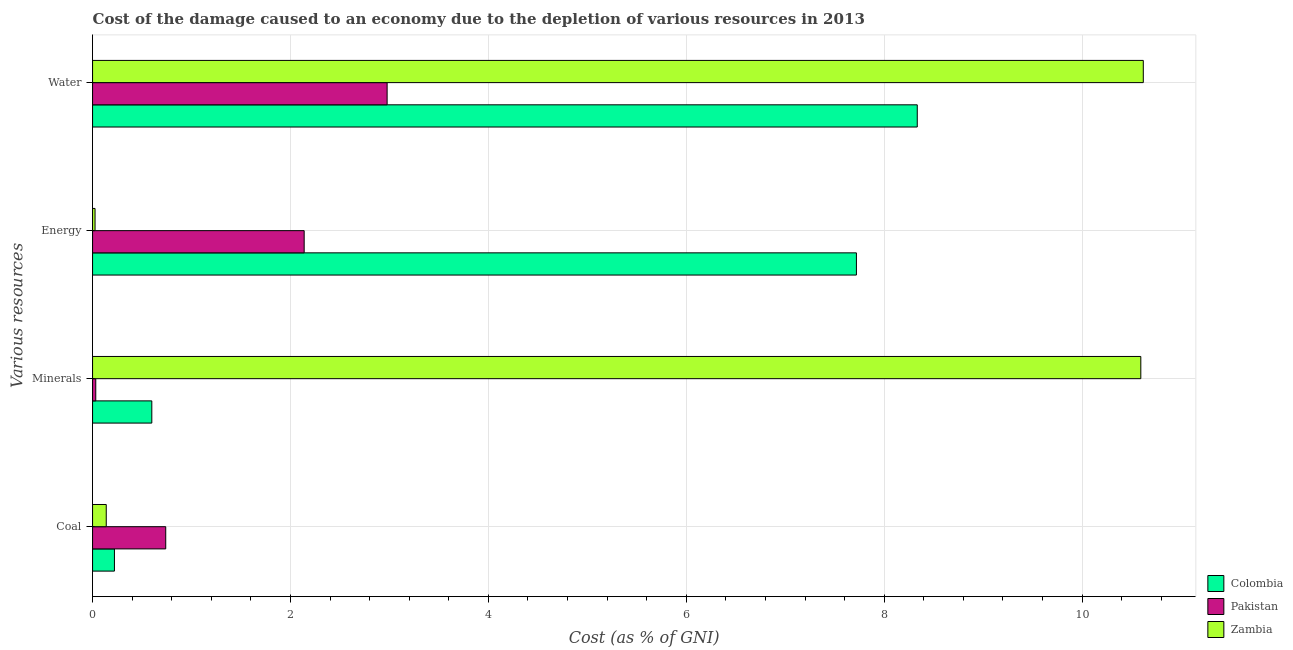How many different coloured bars are there?
Your response must be concise. 3. How many groups of bars are there?
Your answer should be compact. 4. Are the number of bars per tick equal to the number of legend labels?
Offer a terse response. Yes. What is the label of the 3rd group of bars from the top?
Your response must be concise. Minerals. What is the cost of damage due to depletion of water in Pakistan?
Keep it short and to the point. 2.98. Across all countries, what is the maximum cost of damage due to depletion of energy?
Keep it short and to the point. 7.72. Across all countries, what is the minimum cost of damage due to depletion of energy?
Offer a terse response. 0.03. In which country was the cost of damage due to depletion of minerals maximum?
Provide a short and direct response. Zambia. In which country was the cost of damage due to depletion of water minimum?
Your answer should be compact. Pakistan. What is the total cost of damage due to depletion of water in the graph?
Offer a terse response. 21.93. What is the difference between the cost of damage due to depletion of water in Colombia and that in Pakistan?
Ensure brevity in your answer.  5.36. What is the difference between the cost of damage due to depletion of energy in Colombia and the cost of damage due to depletion of water in Pakistan?
Give a very brief answer. 4.74. What is the average cost of damage due to depletion of coal per country?
Give a very brief answer. 0.37. What is the difference between the cost of damage due to depletion of minerals and cost of damage due to depletion of energy in Pakistan?
Ensure brevity in your answer.  -2.11. What is the ratio of the cost of damage due to depletion of energy in Zambia to that in Pakistan?
Offer a terse response. 0.01. Is the difference between the cost of damage due to depletion of minerals in Pakistan and Zambia greater than the difference between the cost of damage due to depletion of energy in Pakistan and Zambia?
Make the answer very short. No. What is the difference between the highest and the second highest cost of damage due to depletion of water?
Provide a succinct answer. 2.28. What is the difference between the highest and the lowest cost of damage due to depletion of minerals?
Make the answer very short. 10.56. What does the 1st bar from the top in Water represents?
Offer a terse response. Zambia. Is it the case that in every country, the sum of the cost of damage due to depletion of coal and cost of damage due to depletion of minerals is greater than the cost of damage due to depletion of energy?
Offer a terse response. No. How many bars are there?
Your answer should be very brief. 12. Are all the bars in the graph horizontal?
Provide a short and direct response. Yes. What is the difference between two consecutive major ticks on the X-axis?
Offer a terse response. 2. Where does the legend appear in the graph?
Your response must be concise. Bottom right. How many legend labels are there?
Provide a short and direct response. 3. What is the title of the graph?
Offer a very short reply. Cost of the damage caused to an economy due to the depletion of various resources in 2013 . What is the label or title of the X-axis?
Your answer should be very brief. Cost (as % of GNI). What is the label or title of the Y-axis?
Your response must be concise. Various resources. What is the Cost (as % of GNI) of Colombia in Coal?
Your answer should be compact. 0.22. What is the Cost (as % of GNI) in Pakistan in Coal?
Give a very brief answer. 0.74. What is the Cost (as % of GNI) of Zambia in Coal?
Provide a short and direct response. 0.14. What is the Cost (as % of GNI) in Colombia in Minerals?
Ensure brevity in your answer.  0.6. What is the Cost (as % of GNI) in Pakistan in Minerals?
Make the answer very short. 0.03. What is the Cost (as % of GNI) of Zambia in Minerals?
Offer a very short reply. 10.59. What is the Cost (as % of GNI) of Colombia in Energy?
Offer a terse response. 7.72. What is the Cost (as % of GNI) in Pakistan in Energy?
Ensure brevity in your answer.  2.14. What is the Cost (as % of GNI) in Zambia in Energy?
Give a very brief answer. 0.03. What is the Cost (as % of GNI) of Colombia in Water?
Your answer should be compact. 8.33. What is the Cost (as % of GNI) in Pakistan in Water?
Offer a very short reply. 2.98. What is the Cost (as % of GNI) in Zambia in Water?
Your response must be concise. 10.62. Across all Various resources, what is the maximum Cost (as % of GNI) in Colombia?
Give a very brief answer. 8.33. Across all Various resources, what is the maximum Cost (as % of GNI) in Pakistan?
Your answer should be very brief. 2.98. Across all Various resources, what is the maximum Cost (as % of GNI) in Zambia?
Offer a very short reply. 10.62. Across all Various resources, what is the minimum Cost (as % of GNI) of Colombia?
Your response must be concise. 0.22. Across all Various resources, what is the minimum Cost (as % of GNI) of Pakistan?
Keep it short and to the point. 0.03. Across all Various resources, what is the minimum Cost (as % of GNI) of Zambia?
Your answer should be compact. 0.03. What is the total Cost (as % of GNI) in Colombia in the graph?
Provide a short and direct response. 16.87. What is the total Cost (as % of GNI) of Pakistan in the graph?
Your response must be concise. 5.89. What is the total Cost (as % of GNI) in Zambia in the graph?
Offer a very short reply. 21.38. What is the difference between the Cost (as % of GNI) in Colombia in Coal and that in Minerals?
Your response must be concise. -0.38. What is the difference between the Cost (as % of GNI) in Pakistan in Coal and that in Minerals?
Offer a terse response. 0.71. What is the difference between the Cost (as % of GNI) in Zambia in Coal and that in Minerals?
Offer a very short reply. -10.46. What is the difference between the Cost (as % of GNI) in Colombia in Coal and that in Energy?
Your response must be concise. -7.5. What is the difference between the Cost (as % of GNI) of Pakistan in Coal and that in Energy?
Keep it short and to the point. -1.4. What is the difference between the Cost (as % of GNI) in Zambia in Coal and that in Energy?
Your answer should be compact. 0.11. What is the difference between the Cost (as % of GNI) in Colombia in Coal and that in Water?
Your answer should be very brief. -8.11. What is the difference between the Cost (as % of GNI) of Pakistan in Coal and that in Water?
Provide a short and direct response. -2.24. What is the difference between the Cost (as % of GNI) of Zambia in Coal and that in Water?
Your response must be concise. -10.48. What is the difference between the Cost (as % of GNI) of Colombia in Minerals and that in Energy?
Offer a very short reply. -7.12. What is the difference between the Cost (as % of GNI) in Pakistan in Minerals and that in Energy?
Give a very brief answer. -2.11. What is the difference between the Cost (as % of GNI) in Zambia in Minerals and that in Energy?
Make the answer very short. 10.57. What is the difference between the Cost (as % of GNI) in Colombia in Minerals and that in Water?
Provide a succinct answer. -7.74. What is the difference between the Cost (as % of GNI) in Pakistan in Minerals and that in Water?
Make the answer very short. -2.94. What is the difference between the Cost (as % of GNI) in Zambia in Minerals and that in Water?
Give a very brief answer. -0.03. What is the difference between the Cost (as % of GNI) in Colombia in Energy and that in Water?
Give a very brief answer. -0.61. What is the difference between the Cost (as % of GNI) of Pakistan in Energy and that in Water?
Offer a terse response. -0.84. What is the difference between the Cost (as % of GNI) of Zambia in Energy and that in Water?
Ensure brevity in your answer.  -10.59. What is the difference between the Cost (as % of GNI) in Colombia in Coal and the Cost (as % of GNI) in Pakistan in Minerals?
Keep it short and to the point. 0.19. What is the difference between the Cost (as % of GNI) of Colombia in Coal and the Cost (as % of GNI) of Zambia in Minerals?
Ensure brevity in your answer.  -10.37. What is the difference between the Cost (as % of GNI) in Pakistan in Coal and the Cost (as % of GNI) in Zambia in Minerals?
Ensure brevity in your answer.  -9.85. What is the difference between the Cost (as % of GNI) in Colombia in Coal and the Cost (as % of GNI) in Pakistan in Energy?
Offer a terse response. -1.92. What is the difference between the Cost (as % of GNI) of Colombia in Coal and the Cost (as % of GNI) of Zambia in Energy?
Provide a succinct answer. 0.2. What is the difference between the Cost (as % of GNI) in Pakistan in Coal and the Cost (as % of GNI) in Zambia in Energy?
Keep it short and to the point. 0.71. What is the difference between the Cost (as % of GNI) in Colombia in Coal and the Cost (as % of GNI) in Pakistan in Water?
Offer a terse response. -2.76. What is the difference between the Cost (as % of GNI) in Colombia in Coal and the Cost (as % of GNI) in Zambia in Water?
Your response must be concise. -10.4. What is the difference between the Cost (as % of GNI) of Pakistan in Coal and the Cost (as % of GNI) of Zambia in Water?
Your answer should be very brief. -9.88. What is the difference between the Cost (as % of GNI) of Colombia in Minerals and the Cost (as % of GNI) of Pakistan in Energy?
Your answer should be very brief. -1.54. What is the difference between the Cost (as % of GNI) in Colombia in Minerals and the Cost (as % of GNI) in Zambia in Energy?
Your response must be concise. 0.57. What is the difference between the Cost (as % of GNI) in Pakistan in Minerals and the Cost (as % of GNI) in Zambia in Energy?
Give a very brief answer. 0.01. What is the difference between the Cost (as % of GNI) in Colombia in Minerals and the Cost (as % of GNI) in Pakistan in Water?
Provide a succinct answer. -2.38. What is the difference between the Cost (as % of GNI) of Colombia in Minerals and the Cost (as % of GNI) of Zambia in Water?
Your answer should be compact. -10.02. What is the difference between the Cost (as % of GNI) in Pakistan in Minerals and the Cost (as % of GNI) in Zambia in Water?
Keep it short and to the point. -10.59. What is the difference between the Cost (as % of GNI) of Colombia in Energy and the Cost (as % of GNI) of Pakistan in Water?
Offer a very short reply. 4.74. What is the difference between the Cost (as % of GNI) in Colombia in Energy and the Cost (as % of GNI) in Zambia in Water?
Ensure brevity in your answer.  -2.9. What is the difference between the Cost (as % of GNI) of Pakistan in Energy and the Cost (as % of GNI) of Zambia in Water?
Your answer should be very brief. -8.48. What is the average Cost (as % of GNI) of Colombia per Various resources?
Your answer should be compact. 4.22. What is the average Cost (as % of GNI) in Pakistan per Various resources?
Offer a very short reply. 1.47. What is the average Cost (as % of GNI) in Zambia per Various resources?
Make the answer very short. 5.34. What is the difference between the Cost (as % of GNI) of Colombia and Cost (as % of GNI) of Pakistan in Coal?
Keep it short and to the point. -0.52. What is the difference between the Cost (as % of GNI) of Colombia and Cost (as % of GNI) of Zambia in Coal?
Offer a very short reply. 0.08. What is the difference between the Cost (as % of GNI) of Pakistan and Cost (as % of GNI) of Zambia in Coal?
Provide a short and direct response. 0.6. What is the difference between the Cost (as % of GNI) in Colombia and Cost (as % of GNI) in Pakistan in Minerals?
Your response must be concise. 0.57. What is the difference between the Cost (as % of GNI) of Colombia and Cost (as % of GNI) of Zambia in Minerals?
Provide a short and direct response. -9.99. What is the difference between the Cost (as % of GNI) in Pakistan and Cost (as % of GNI) in Zambia in Minerals?
Keep it short and to the point. -10.56. What is the difference between the Cost (as % of GNI) in Colombia and Cost (as % of GNI) in Pakistan in Energy?
Keep it short and to the point. 5.58. What is the difference between the Cost (as % of GNI) in Colombia and Cost (as % of GNI) in Zambia in Energy?
Your answer should be compact. 7.69. What is the difference between the Cost (as % of GNI) of Pakistan and Cost (as % of GNI) of Zambia in Energy?
Offer a terse response. 2.11. What is the difference between the Cost (as % of GNI) of Colombia and Cost (as % of GNI) of Pakistan in Water?
Ensure brevity in your answer.  5.36. What is the difference between the Cost (as % of GNI) of Colombia and Cost (as % of GNI) of Zambia in Water?
Your response must be concise. -2.28. What is the difference between the Cost (as % of GNI) in Pakistan and Cost (as % of GNI) in Zambia in Water?
Offer a terse response. -7.64. What is the ratio of the Cost (as % of GNI) in Colombia in Coal to that in Minerals?
Make the answer very short. 0.37. What is the ratio of the Cost (as % of GNI) in Pakistan in Coal to that in Minerals?
Offer a terse response. 22.92. What is the ratio of the Cost (as % of GNI) in Zambia in Coal to that in Minerals?
Offer a terse response. 0.01. What is the ratio of the Cost (as % of GNI) of Colombia in Coal to that in Energy?
Ensure brevity in your answer.  0.03. What is the ratio of the Cost (as % of GNI) in Pakistan in Coal to that in Energy?
Keep it short and to the point. 0.35. What is the ratio of the Cost (as % of GNI) of Zambia in Coal to that in Energy?
Make the answer very short. 5.52. What is the ratio of the Cost (as % of GNI) of Colombia in Coal to that in Water?
Offer a terse response. 0.03. What is the ratio of the Cost (as % of GNI) in Pakistan in Coal to that in Water?
Give a very brief answer. 0.25. What is the ratio of the Cost (as % of GNI) of Zambia in Coal to that in Water?
Offer a terse response. 0.01. What is the ratio of the Cost (as % of GNI) of Colombia in Minerals to that in Energy?
Keep it short and to the point. 0.08. What is the ratio of the Cost (as % of GNI) of Pakistan in Minerals to that in Energy?
Offer a very short reply. 0.02. What is the ratio of the Cost (as % of GNI) in Zambia in Minerals to that in Energy?
Your answer should be compact. 422.8. What is the ratio of the Cost (as % of GNI) of Colombia in Minerals to that in Water?
Keep it short and to the point. 0.07. What is the ratio of the Cost (as % of GNI) in Pakistan in Minerals to that in Water?
Your answer should be compact. 0.01. What is the ratio of the Cost (as % of GNI) in Zambia in Minerals to that in Water?
Ensure brevity in your answer.  1. What is the ratio of the Cost (as % of GNI) of Colombia in Energy to that in Water?
Give a very brief answer. 0.93. What is the ratio of the Cost (as % of GNI) of Pakistan in Energy to that in Water?
Ensure brevity in your answer.  0.72. What is the ratio of the Cost (as % of GNI) in Zambia in Energy to that in Water?
Your answer should be very brief. 0. What is the difference between the highest and the second highest Cost (as % of GNI) of Colombia?
Offer a terse response. 0.61. What is the difference between the highest and the second highest Cost (as % of GNI) in Pakistan?
Make the answer very short. 0.84. What is the difference between the highest and the second highest Cost (as % of GNI) of Zambia?
Provide a short and direct response. 0.03. What is the difference between the highest and the lowest Cost (as % of GNI) of Colombia?
Make the answer very short. 8.11. What is the difference between the highest and the lowest Cost (as % of GNI) of Pakistan?
Your response must be concise. 2.94. What is the difference between the highest and the lowest Cost (as % of GNI) of Zambia?
Give a very brief answer. 10.59. 